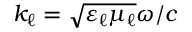<formula> <loc_0><loc_0><loc_500><loc_500>k _ { \ell } = \sqrt { \varepsilon _ { \ell } \mu _ { \ell } } \omega / c</formula> 